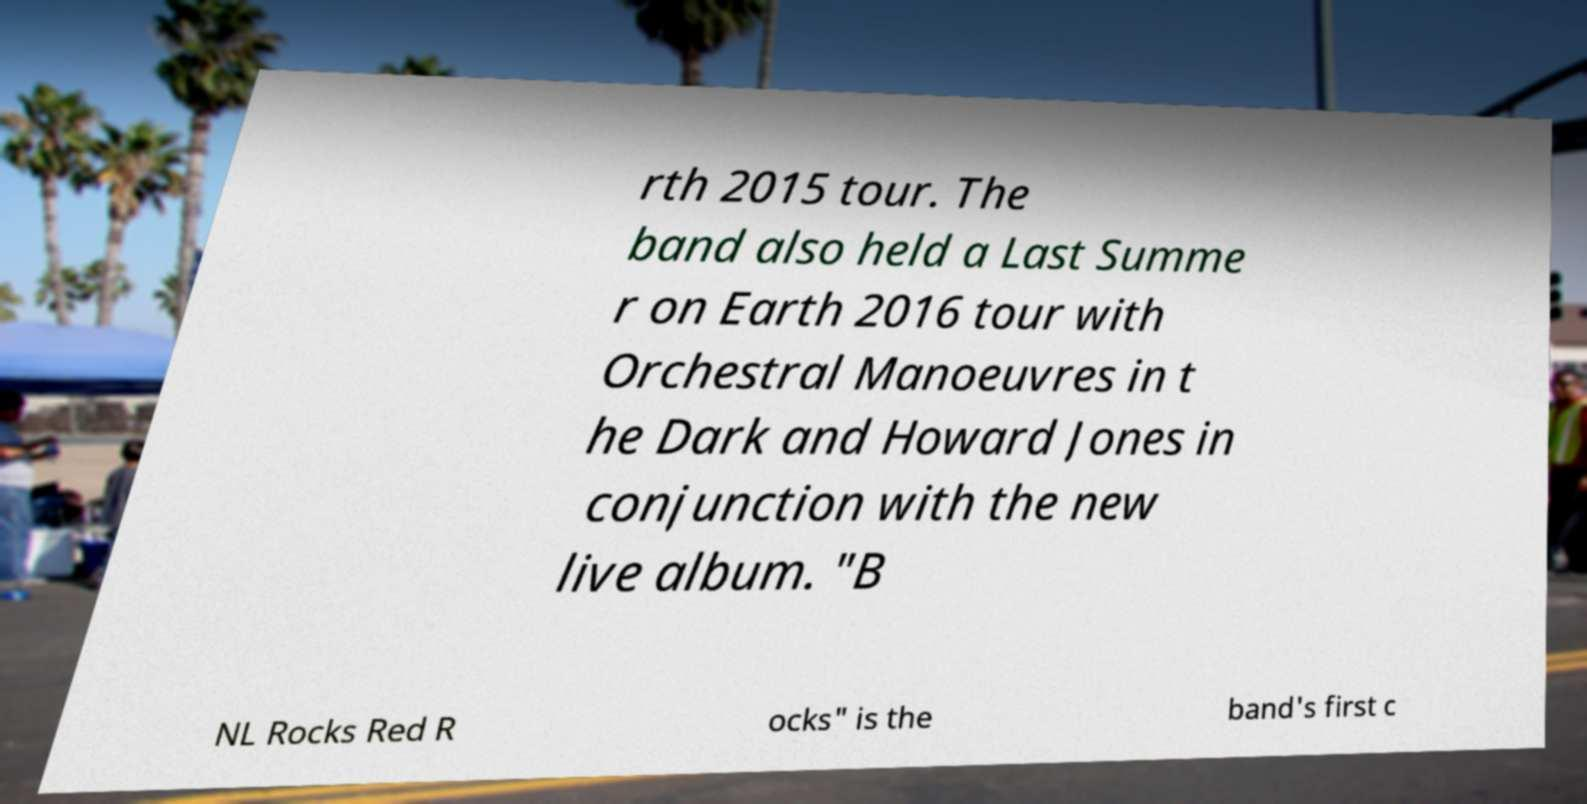Can you read and provide the text displayed in the image?This photo seems to have some interesting text. Can you extract and type it out for me? rth 2015 tour. The band also held a Last Summe r on Earth 2016 tour with Orchestral Manoeuvres in t he Dark and Howard Jones in conjunction with the new live album. "B NL Rocks Red R ocks" is the band's first c 